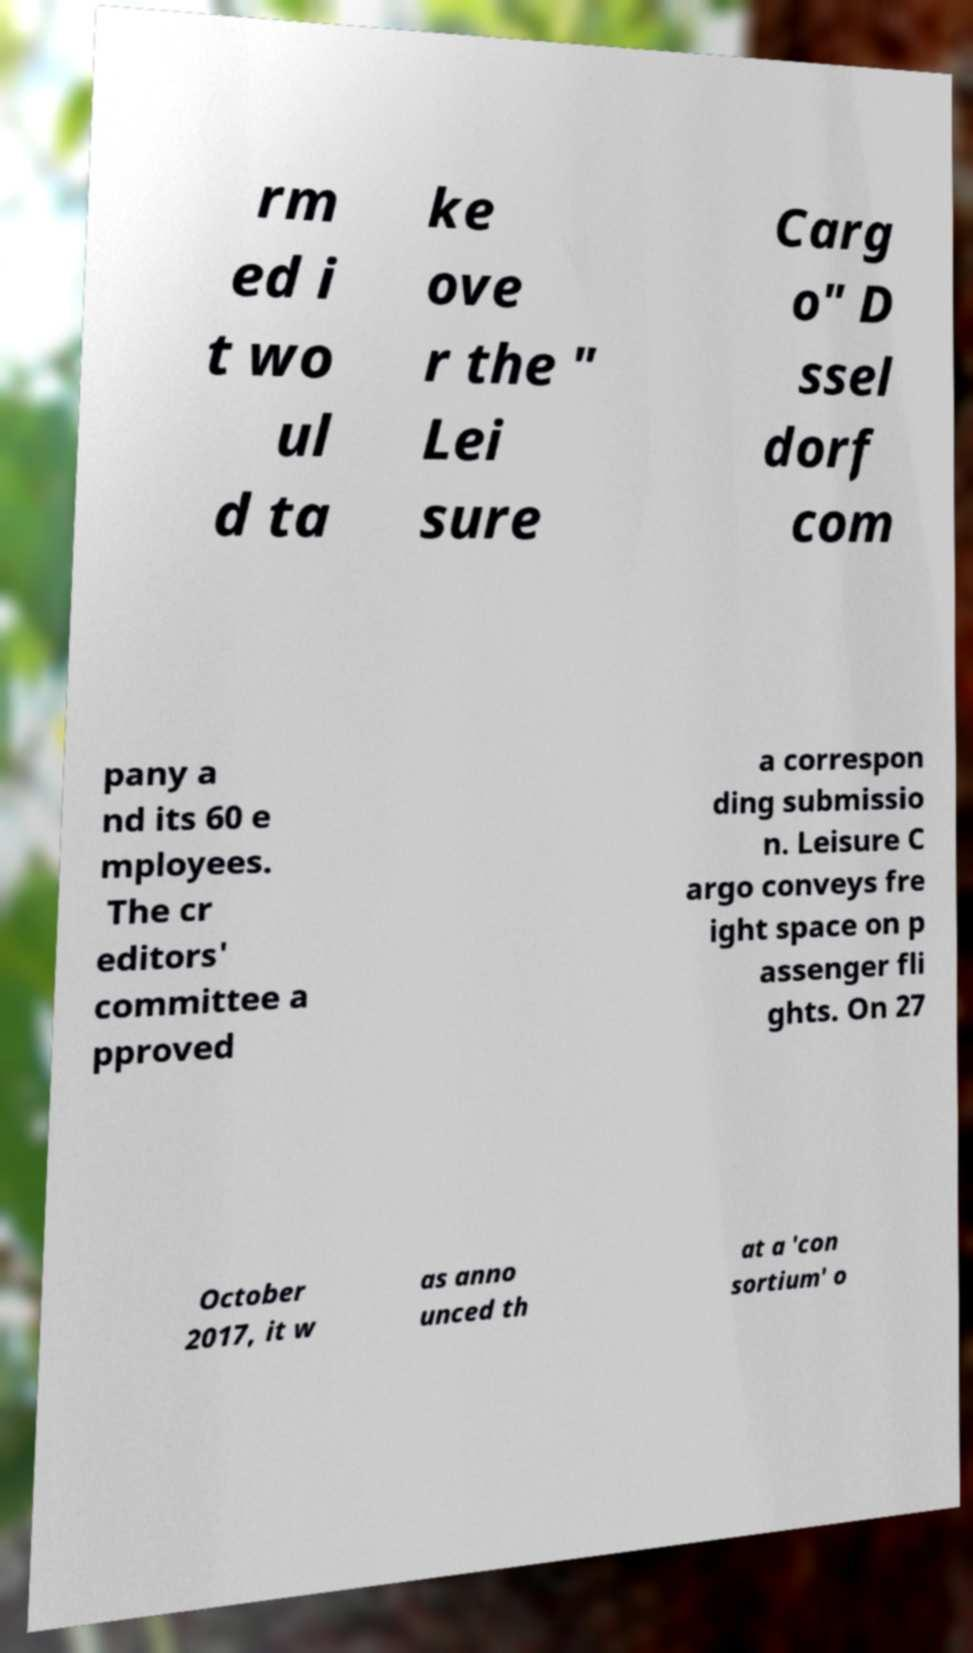Can you read and provide the text displayed in the image?This photo seems to have some interesting text. Can you extract and type it out for me? rm ed i t wo ul d ta ke ove r the " Lei sure Carg o" D ssel dorf com pany a nd its 60 e mployees. The cr editors' committee a pproved a correspon ding submissio n. Leisure C argo conveys fre ight space on p assenger fli ghts. On 27 October 2017, it w as anno unced th at a 'con sortium' o 